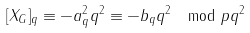Convert formula to latex. <formula><loc_0><loc_0><loc_500><loc_500>[ X _ { G } ] _ { q } \equiv - a ^ { 2 } _ { q } q ^ { 2 } \equiv - b _ { q } q ^ { 2 } \mod p q ^ { 2 }</formula> 